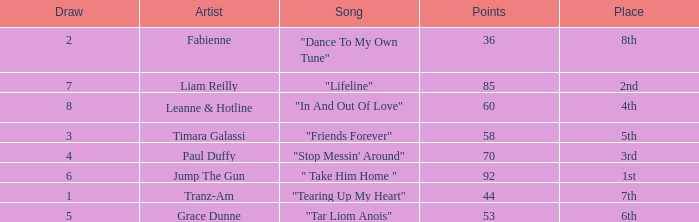What's the average amount of points for "in and out of love" with a draw over 8? None. 